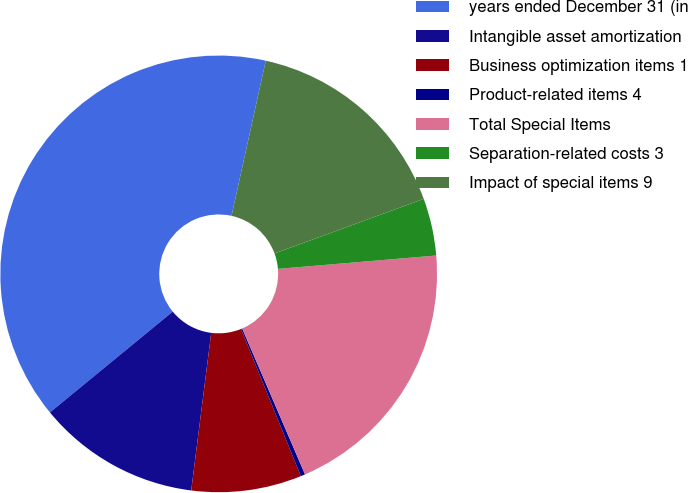<chart> <loc_0><loc_0><loc_500><loc_500><pie_chart><fcel>years ended December 31 (in<fcel>Intangible asset amortization<fcel>Business optimization items 1<fcel>Product-related items 4<fcel>Total Special Items<fcel>Separation-related costs 3<fcel>Impact of special items 9<nl><fcel>39.4%<fcel>12.05%<fcel>8.15%<fcel>0.33%<fcel>19.87%<fcel>4.24%<fcel>15.96%<nl></chart> 